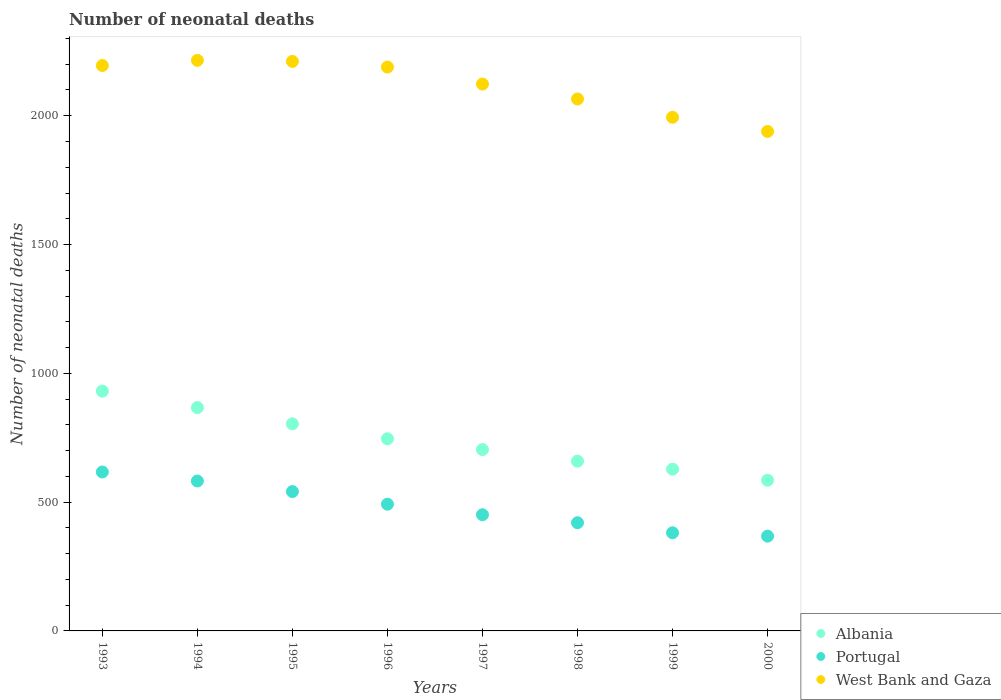What is the number of neonatal deaths in in Portugal in 1993?
Provide a succinct answer. 617. Across all years, what is the maximum number of neonatal deaths in in Portugal?
Make the answer very short. 617. Across all years, what is the minimum number of neonatal deaths in in Portugal?
Ensure brevity in your answer.  368. What is the total number of neonatal deaths in in Albania in the graph?
Your answer should be very brief. 5924. What is the difference between the number of neonatal deaths in in Albania in 1993 and that in 1998?
Make the answer very short. 272. What is the difference between the number of neonatal deaths in in West Bank and Gaza in 1998 and the number of neonatal deaths in in Albania in 1997?
Give a very brief answer. 1361. What is the average number of neonatal deaths in in Albania per year?
Offer a terse response. 740.5. In the year 1998, what is the difference between the number of neonatal deaths in in West Bank and Gaza and number of neonatal deaths in in Albania?
Your answer should be very brief. 1406. What is the ratio of the number of neonatal deaths in in Portugal in 1995 to that in 1999?
Offer a terse response. 1.42. What is the difference between the highest and the second highest number of neonatal deaths in in West Bank and Gaza?
Your response must be concise. 4. What is the difference between the highest and the lowest number of neonatal deaths in in Albania?
Ensure brevity in your answer.  346. Is the sum of the number of neonatal deaths in in Portugal in 1998 and 1999 greater than the maximum number of neonatal deaths in in Albania across all years?
Your response must be concise. No. Is it the case that in every year, the sum of the number of neonatal deaths in in Albania and number of neonatal deaths in in West Bank and Gaza  is greater than the number of neonatal deaths in in Portugal?
Give a very brief answer. Yes. Does the number of neonatal deaths in in Albania monotonically increase over the years?
Your answer should be very brief. No. Is the number of neonatal deaths in in Portugal strictly less than the number of neonatal deaths in in Albania over the years?
Provide a short and direct response. Yes. How many years are there in the graph?
Your response must be concise. 8. What is the difference between two consecutive major ticks on the Y-axis?
Provide a short and direct response. 500. Does the graph contain grids?
Ensure brevity in your answer.  No. How many legend labels are there?
Make the answer very short. 3. What is the title of the graph?
Make the answer very short. Number of neonatal deaths. What is the label or title of the Y-axis?
Provide a succinct answer. Number of neonatal deaths. What is the Number of neonatal deaths in Albania in 1993?
Give a very brief answer. 931. What is the Number of neonatal deaths of Portugal in 1993?
Provide a succinct answer. 617. What is the Number of neonatal deaths in West Bank and Gaza in 1993?
Offer a terse response. 2195. What is the Number of neonatal deaths in Albania in 1994?
Offer a terse response. 867. What is the Number of neonatal deaths of Portugal in 1994?
Your answer should be compact. 582. What is the Number of neonatal deaths in West Bank and Gaza in 1994?
Give a very brief answer. 2215. What is the Number of neonatal deaths in Albania in 1995?
Ensure brevity in your answer.  804. What is the Number of neonatal deaths of Portugal in 1995?
Offer a terse response. 541. What is the Number of neonatal deaths of West Bank and Gaza in 1995?
Make the answer very short. 2211. What is the Number of neonatal deaths in Albania in 1996?
Provide a short and direct response. 746. What is the Number of neonatal deaths of Portugal in 1996?
Offer a very short reply. 492. What is the Number of neonatal deaths in West Bank and Gaza in 1996?
Your response must be concise. 2189. What is the Number of neonatal deaths of Albania in 1997?
Provide a succinct answer. 704. What is the Number of neonatal deaths of Portugal in 1997?
Provide a succinct answer. 451. What is the Number of neonatal deaths in West Bank and Gaza in 1997?
Provide a short and direct response. 2123. What is the Number of neonatal deaths of Albania in 1998?
Offer a terse response. 659. What is the Number of neonatal deaths of Portugal in 1998?
Give a very brief answer. 420. What is the Number of neonatal deaths in West Bank and Gaza in 1998?
Offer a very short reply. 2065. What is the Number of neonatal deaths of Albania in 1999?
Offer a terse response. 628. What is the Number of neonatal deaths in Portugal in 1999?
Provide a short and direct response. 381. What is the Number of neonatal deaths of West Bank and Gaza in 1999?
Provide a succinct answer. 1994. What is the Number of neonatal deaths in Albania in 2000?
Make the answer very short. 585. What is the Number of neonatal deaths of Portugal in 2000?
Your answer should be very brief. 368. What is the Number of neonatal deaths in West Bank and Gaza in 2000?
Ensure brevity in your answer.  1939. Across all years, what is the maximum Number of neonatal deaths in Albania?
Offer a terse response. 931. Across all years, what is the maximum Number of neonatal deaths of Portugal?
Ensure brevity in your answer.  617. Across all years, what is the maximum Number of neonatal deaths in West Bank and Gaza?
Keep it short and to the point. 2215. Across all years, what is the minimum Number of neonatal deaths of Albania?
Make the answer very short. 585. Across all years, what is the minimum Number of neonatal deaths in Portugal?
Your answer should be compact. 368. Across all years, what is the minimum Number of neonatal deaths in West Bank and Gaza?
Provide a succinct answer. 1939. What is the total Number of neonatal deaths of Albania in the graph?
Give a very brief answer. 5924. What is the total Number of neonatal deaths in Portugal in the graph?
Give a very brief answer. 3852. What is the total Number of neonatal deaths in West Bank and Gaza in the graph?
Make the answer very short. 1.69e+04. What is the difference between the Number of neonatal deaths of Albania in 1993 and that in 1994?
Give a very brief answer. 64. What is the difference between the Number of neonatal deaths in Portugal in 1993 and that in 1994?
Make the answer very short. 35. What is the difference between the Number of neonatal deaths in Albania in 1993 and that in 1995?
Provide a succinct answer. 127. What is the difference between the Number of neonatal deaths in Portugal in 1993 and that in 1995?
Your answer should be compact. 76. What is the difference between the Number of neonatal deaths in West Bank and Gaza in 1993 and that in 1995?
Give a very brief answer. -16. What is the difference between the Number of neonatal deaths in Albania in 1993 and that in 1996?
Your answer should be compact. 185. What is the difference between the Number of neonatal deaths of Portugal in 1993 and that in 1996?
Your answer should be compact. 125. What is the difference between the Number of neonatal deaths in Albania in 1993 and that in 1997?
Provide a succinct answer. 227. What is the difference between the Number of neonatal deaths of Portugal in 1993 and that in 1997?
Your answer should be compact. 166. What is the difference between the Number of neonatal deaths of Albania in 1993 and that in 1998?
Offer a very short reply. 272. What is the difference between the Number of neonatal deaths in Portugal in 1993 and that in 1998?
Offer a terse response. 197. What is the difference between the Number of neonatal deaths in West Bank and Gaza in 1993 and that in 1998?
Offer a terse response. 130. What is the difference between the Number of neonatal deaths in Albania in 1993 and that in 1999?
Make the answer very short. 303. What is the difference between the Number of neonatal deaths of Portugal in 1993 and that in 1999?
Offer a very short reply. 236. What is the difference between the Number of neonatal deaths of West Bank and Gaza in 1993 and that in 1999?
Your response must be concise. 201. What is the difference between the Number of neonatal deaths of Albania in 1993 and that in 2000?
Provide a short and direct response. 346. What is the difference between the Number of neonatal deaths in Portugal in 1993 and that in 2000?
Keep it short and to the point. 249. What is the difference between the Number of neonatal deaths of West Bank and Gaza in 1993 and that in 2000?
Your answer should be very brief. 256. What is the difference between the Number of neonatal deaths of Portugal in 1994 and that in 1995?
Your answer should be compact. 41. What is the difference between the Number of neonatal deaths in Albania in 1994 and that in 1996?
Provide a short and direct response. 121. What is the difference between the Number of neonatal deaths in West Bank and Gaza in 1994 and that in 1996?
Offer a very short reply. 26. What is the difference between the Number of neonatal deaths of Albania in 1994 and that in 1997?
Offer a terse response. 163. What is the difference between the Number of neonatal deaths of Portugal in 1994 and that in 1997?
Provide a short and direct response. 131. What is the difference between the Number of neonatal deaths in West Bank and Gaza in 1994 and that in 1997?
Your answer should be compact. 92. What is the difference between the Number of neonatal deaths in Albania in 1994 and that in 1998?
Keep it short and to the point. 208. What is the difference between the Number of neonatal deaths of Portugal in 1994 and that in 1998?
Ensure brevity in your answer.  162. What is the difference between the Number of neonatal deaths of West Bank and Gaza in 1994 and that in 1998?
Provide a short and direct response. 150. What is the difference between the Number of neonatal deaths of Albania in 1994 and that in 1999?
Ensure brevity in your answer.  239. What is the difference between the Number of neonatal deaths of Portugal in 1994 and that in 1999?
Give a very brief answer. 201. What is the difference between the Number of neonatal deaths of West Bank and Gaza in 1994 and that in 1999?
Offer a terse response. 221. What is the difference between the Number of neonatal deaths in Albania in 1994 and that in 2000?
Give a very brief answer. 282. What is the difference between the Number of neonatal deaths in Portugal in 1994 and that in 2000?
Your response must be concise. 214. What is the difference between the Number of neonatal deaths of West Bank and Gaza in 1994 and that in 2000?
Give a very brief answer. 276. What is the difference between the Number of neonatal deaths in West Bank and Gaza in 1995 and that in 1996?
Provide a succinct answer. 22. What is the difference between the Number of neonatal deaths in Albania in 1995 and that in 1997?
Ensure brevity in your answer.  100. What is the difference between the Number of neonatal deaths in Albania in 1995 and that in 1998?
Your answer should be compact. 145. What is the difference between the Number of neonatal deaths in Portugal in 1995 and that in 1998?
Give a very brief answer. 121. What is the difference between the Number of neonatal deaths in West Bank and Gaza in 1995 and that in 1998?
Your answer should be very brief. 146. What is the difference between the Number of neonatal deaths of Albania in 1995 and that in 1999?
Provide a short and direct response. 176. What is the difference between the Number of neonatal deaths in Portugal in 1995 and that in 1999?
Ensure brevity in your answer.  160. What is the difference between the Number of neonatal deaths of West Bank and Gaza in 1995 and that in 1999?
Your answer should be compact. 217. What is the difference between the Number of neonatal deaths in Albania in 1995 and that in 2000?
Your response must be concise. 219. What is the difference between the Number of neonatal deaths in Portugal in 1995 and that in 2000?
Provide a succinct answer. 173. What is the difference between the Number of neonatal deaths in West Bank and Gaza in 1995 and that in 2000?
Offer a very short reply. 272. What is the difference between the Number of neonatal deaths of Albania in 1996 and that in 1997?
Your response must be concise. 42. What is the difference between the Number of neonatal deaths in West Bank and Gaza in 1996 and that in 1997?
Offer a very short reply. 66. What is the difference between the Number of neonatal deaths in Albania in 1996 and that in 1998?
Provide a short and direct response. 87. What is the difference between the Number of neonatal deaths of Portugal in 1996 and that in 1998?
Offer a very short reply. 72. What is the difference between the Number of neonatal deaths of West Bank and Gaza in 1996 and that in 1998?
Give a very brief answer. 124. What is the difference between the Number of neonatal deaths of Albania in 1996 and that in 1999?
Your answer should be very brief. 118. What is the difference between the Number of neonatal deaths in Portugal in 1996 and that in 1999?
Offer a terse response. 111. What is the difference between the Number of neonatal deaths of West Bank and Gaza in 1996 and that in 1999?
Provide a short and direct response. 195. What is the difference between the Number of neonatal deaths of Albania in 1996 and that in 2000?
Your response must be concise. 161. What is the difference between the Number of neonatal deaths in Portugal in 1996 and that in 2000?
Give a very brief answer. 124. What is the difference between the Number of neonatal deaths of West Bank and Gaza in 1996 and that in 2000?
Provide a succinct answer. 250. What is the difference between the Number of neonatal deaths in Albania in 1997 and that in 1998?
Ensure brevity in your answer.  45. What is the difference between the Number of neonatal deaths in Portugal in 1997 and that in 1998?
Provide a succinct answer. 31. What is the difference between the Number of neonatal deaths of West Bank and Gaza in 1997 and that in 1998?
Ensure brevity in your answer.  58. What is the difference between the Number of neonatal deaths of West Bank and Gaza in 1997 and that in 1999?
Provide a short and direct response. 129. What is the difference between the Number of neonatal deaths in Albania in 1997 and that in 2000?
Provide a short and direct response. 119. What is the difference between the Number of neonatal deaths in West Bank and Gaza in 1997 and that in 2000?
Your answer should be very brief. 184. What is the difference between the Number of neonatal deaths in Albania in 1998 and that in 1999?
Your response must be concise. 31. What is the difference between the Number of neonatal deaths in Portugal in 1998 and that in 1999?
Provide a succinct answer. 39. What is the difference between the Number of neonatal deaths in West Bank and Gaza in 1998 and that in 1999?
Provide a succinct answer. 71. What is the difference between the Number of neonatal deaths in West Bank and Gaza in 1998 and that in 2000?
Provide a short and direct response. 126. What is the difference between the Number of neonatal deaths in Portugal in 1999 and that in 2000?
Offer a terse response. 13. What is the difference between the Number of neonatal deaths in West Bank and Gaza in 1999 and that in 2000?
Provide a succinct answer. 55. What is the difference between the Number of neonatal deaths in Albania in 1993 and the Number of neonatal deaths in Portugal in 1994?
Provide a short and direct response. 349. What is the difference between the Number of neonatal deaths of Albania in 1993 and the Number of neonatal deaths of West Bank and Gaza in 1994?
Provide a succinct answer. -1284. What is the difference between the Number of neonatal deaths of Portugal in 1993 and the Number of neonatal deaths of West Bank and Gaza in 1994?
Make the answer very short. -1598. What is the difference between the Number of neonatal deaths of Albania in 1993 and the Number of neonatal deaths of Portugal in 1995?
Offer a very short reply. 390. What is the difference between the Number of neonatal deaths of Albania in 1993 and the Number of neonatal deaths of West Bank and Gaza in 1995?
Make the answer very short. -1280. What is the difference between the Number of neonatal deaths in Portugal in 1993 and the Number of neonatal deaths in West Bank and Gaza in 1995?
Ensure brevity in your answer.  -1594. What is the difference between the Number of neonatal deaths in Albania in 1993 and the Number of neonatal deaths in Portugal in 1996?
Provide a succinct answer. 439. What is the difference between the Number of neonatal deaths in Albania in 1993 and the Number of neonatal deaths in West Bank and Gaza in 1996?
Keep it short and to the point. -1258. What is the difference between the Number of neonatal deaths of Portugal in 1993 and the Number of neonatal deaths of West Bank and Gaza in 1996?
Keep it short and to the point. -1572. What is the difference between the Number of neonatal deaths of Albania in 1993 and the Number of neonatal deaths of Portugal in 1997?
Provide a short and direct response. 480. What is the difference between the Number of neonatal deaths of Albania in 1993 and the Number of neonatal deaths of West Bank and Gaza in 1997?
Offer a terse response. -1192. What is the difference between the Number of neonatal deaths in Portugal in 1993 and the Number of neonatal deaths in West Bank and Gaza in 1997?
Provide a succinct answer. -1506. What is the difference between the Number of neonatal deaths of Albania in 1993 and the Number of neonatal deaths of Portugal in 1998?
Your response must be concise. 511. What is the difference between the Number of neonatal deaths of Albania in 1993 and the Number of neonatal deaths of West Bank and Gaza in 1998?
Keep it short and to the point. -1134. What is the difference between the Number of neonatal deaths of Portugal in 1993 and the Number of neonatal deaths of West Bank and Gaza in 1998?
Give a very brief answer. -1448. What is the difference between the Number of neonatal deaths in Albania in 1993 and the Number of neonatal deaths in Portugal in 1999?
Give a very brief answer. 550. What is the difference between the Number of neonatal deaths of Albania in 1993 and the Number of neonatal deaths of West Bank and Gaza in 1999?
Your response must be concise. -1063. What is the difference between the Number of neonatal deaths of Portugal in 1993 and the Number of neonatal deaths of West Bank and Gaza in 1999?
Your response must be concise. -1377. What is the difference between the Number of neonatal deaths of Albania in 1993 and the Number of neonatal deaths of Portugal in 2000?
Your answer should be compact. 563. What is the difference between the Number of neonatal deaths of Albania in 1993 and the Number of neonatal deaths of West Bank and Gaza in 2000?
Offer a very short reply. -1008. What is the difference between the Number of neonatal deaths of Portugal in 1993 and the Number of neonatal deaths of West Bank and Gaza in 2000?
Offer a very short reply. -1322. What is the difference between the Number of neonatal deaths in Albania in 1994 and the Number of neonatal deaths in Portugal in 1995?
Keep it short and to the point. 326. What is the difference between the Number of neonatal deaths in Albania in 1994 and the Number of neonatal deaths in West Bank and Gaza in 1995?
Your response must be concise. -1344. What is the difference between the Number of neonatal deaths of Portugal in 1994 and the Number of neonatal deaths of West Bank and Gaza in 1995?
Your response must be concise. -1629. What is the difference between the Number of neonatal deaths in Albania in 1994 and the Number of neonatal deaths in Portugal in 1996?
Your answer should be very brief. 375. What is the difference between the Number of neonatal deaths of Albania in 1994 and the Number of neonatal deaths of West Bank and Gaza in 1996?
Provide a short and direct response. -1322. What is the difference between the Number of neonatal deaths in Portugal in 1994 and the Number of neonatal deaths in West Bank and Gaza in 1996?
Provide a short and direct response. -1607. What is the difference between the Number of neonatal deaths of Albania in 1994 and the Number of neonatal deaths of Portugal in 1997?
Ensure brevity in your answer.  416. What is the difference between the Number of neonatal deaths in Albania in 1994 and the Number of neonatal deaths in West Bank and Gaza in 1997?
Your answer should be compact. -1256. What is the difference between the Number of neonatal deaths in Portugal in 1994 and the Number of neonatal deaths in West Bank and Gaza in 1997?
Your answer should be compact. -1541. What is the difference between the Number of neonatal deaths in Albania in 1994 and the Number of neonatal deaths in Portugal in 1998?
Offer a very short reply. 447. What is the difference between the Number of neonatal deaths in Albania in 1994 and the Number of neonatal deaths in West Bank and Gaza in 1998?
Provide a short and direct response. -1198. What is the difference between the Number of neonatal deaths of Portugal in 1994 and the Number of neonatal deaths of West Bank and Gaza in 1998?
Make the answer very short. -1483. What is the difference between the Number of neonatal deaths in Albania in 1994 and the Number of neonatal deaths in Portugal in 1999?
Keep it short and to the point. 486. What is the difference between the Number of neonatal deaths of Albania in 1994 and the Number of neonatal deaths of West Bank and Gaza in 1999?
Provide a succinct answer. -1127. What is the difference between the Number of neonatal deaths in Portugal in 1994 and the Number of neonatal deaths in West Bank and Gaza in 1999?
Your answer should be very brief. -1412. What is the difference between the Number of neonatal deaths in Albania in 1994 and the Number of neonatal deaths in Portugal in 2000?
Give a very brief answer. 499. What is the difference between the Number of neonatal deaths of Albania in 1994 and the Number of neonatal deaths of West Bank and Gaza in 2000?
Provide a succinct answer. -1072. What is the difference between the Number of neonatal deaths in Portugal in 1994 and the Number of neonatal deaths in West Bank and Gaza in 2000?
Offer a terse response. -1357. What is the difference between the Number of neonatal deaths of Albania in 1995 and the Number of neonatal deaths of Portugal in 1996?
Keep it short and to the point. 312. What is the difference between the Number of neonatal deaths in Albania in 1995 and the Number of neonatal deaths in West Bank and Gaza in 1996?
Ensure brevity in your answer.  -1385. What is the difference between the Number of neonatal deaths of Portugal in 1995 and the Number of neonatal deaths of West Bank and Gaza in 1996?
Your answer should be compact. -1648. What is the difference between the Number of neonatal deaths in Albania in 1995 and the Number of neonatal deaths in Portugal in 1997?
Make the answer very short. 353. What is the difference between the Number of neonatal deaths of Albania in 1995 and the Number of neonatal deaths of West Bank and Gaza in 1997?
Offer a terse response. -1319. What is the difference between the Number of neonatal deaths of Portugal in 1995 and the Number of neonatal deaths of West Bank and Gaza in 1997?
Your response must be concise. -1582. What is the difference between the Number of neonatal deaths in Albania in 1995 and the Number of neonatal deaths in Portugal in 1998?
Offer a very short reply. 384. What is the difference between the Number of neonatal deaths of Albania in 1995 and the Number of neonatal deaths of West Bank and Gaza in 1998?
Offer a very short reply. -1261. What is the difference between the Number of neonatal deaths of Portugal in 1995 and the Number of neonatal deaths of West Bank and Gaza in 1998?
Keep it short and to the point. -1524. What is the difference between the Number of neonatal deaths of Albania in 1995 and the Number of neonatal deaths of Portugal in 1999?
Ensure brevity in your answer.  423. What is the difference between the Number of neonatal deaths of Albania in 1995 and the Number of neonatal deaths of West Bank and Gaza in 1999?
Keep it short and to the point. -1190. What is the difference between the Number of neonatal deaths of Portugal in 1995 and the Number of neonatal deaths of West Bank and Gaza in 1999?
Make the answer very short. -1453. What is the difference between the Number of neonatal deaths of Albania in 1995 and the Number of neonatal deaths of Portugal in 2000?
Your answer should be compact. 436. What is the difference between the Number of neonatal deaths of Albania in 1995 and the Number of neonatal deaths of West Bank and Gaza in 2000?
Your response must be concise. -1135. What is the difference between the Number of neonatal deaths in Portugal in 1995 and the Number of neonatal deaths in West Bank and Gaza in 2000?
Offer a terse response. -1398. What is the difference between the Number of neonatal deaths in Albania in 1996 and the Number of neonatal deaths in Portugal in 1997?
Ensure brevity in your answer.  295. What is the difference between the Number of neonatal deaths in Albania in 1996 and the Number of neonatal deaths in West Bank and Gaza in 1997?
Ensure brevity in your answer.  -1377. What is the difference between the Number of neonatal deaths of Portugal in 1996 and the Number of neonatal deaths of West Bank and Gaza in 1997?
Offer a terse response. -1631. What is the difference between the Number of neonatal deaths in Albania in 1996 and the Number of neonatal deaths in Portugal in 1998?
Make the answer very short. 326. What is the difference between the Number of neonatal deaths of Albania in 1996 and the Number of neonatal deaths of West Bank and Gaza in 1998?
Provide a succinct answer. -1319. What is the difference between the Number of neonatal deaths in Portugal in 1996 and the Number of neonatal deaths in West Bank and Gaza in 1998?
Your answer should be compact. -1573. What is the difference between the Number of neonatal deaths in Albania in 1996 and the Number of neonatal deaths in Portugal in 1999?
Make the answer very short. 365. What is the difference between the Number of neonatal deaths of Albania in 1996 and the Number of neonatal deaths of West Bank and Gaza in 1999?
Offer a terse response. -1248. What is the difference between the Number of neonatal deaths in Portugal in 1996 and the Number of neonatal deaths in West Bank and Gaza in 1999?
Keep it short and to the point. -1502. What is the difference between the Number of neonatal deaths of Albania in 1996 and the Number of neonatal deaths of Portugal in 2000?
Offer a very short reply. 378. What is the difference between the Number of neonatal deaths of Albania in 1996 and the Number of neonatal deaths of West Bank and Gaza in 2000?
Offer a terse response. -1193. What is the difference between the Number of neonatal deaths in Portugal in 1996 and the Number of neonatal deaths in West Bank and Gaza in 2000?
Your answer should be compact. -1447. What is the difference between the Number of neonatal deaths of Albania in 1997 and the Number of neonatal deaths of Portugal in 1998?
Make the answer very short. 284. What is the difference between the Number of neonatal deaths of Albania in 1997 and the Number of neonatal deaths of West Bank and Gaza in 1998?
Your response must be concise. -1361. What is the difference between the Number of neonatal deaths of Portugal in 1997 and the Number of neonatal deaths of West Bank and Gaza in 1998?
Ensure brevity in your answer.  -1614. What is the difference between the Number of neonatal deaths of Albania in 1997 and the Number of neonatal deaths of Portugal in 1999?
Your response must be concise. 323. What is the difference between the Number of neonatal deaths in Albania in 1997 and the Number of neonatal deaths in West Bank and Gaza in 1999?
Your response must be concise. -1290. What is the difference between the Number of neonatal deaths of Portugal in 1997 and the Number of neonatal deaths of West Bank and Gaza in 1999?
Give a very brief answer. -1543. What is the difference between the Number of neonatal deaths of Albania in 1997 and the Number of neonatal deaths of Portugal in 2000?
Your response must be concise. 336. What is the difference between the Number of neonatal deaths in Albania in 1997 and the Number of neonatal deaths in West Bank and Gaza in 2000?
Keep it short and to the point. -1235. What is the difference between the Number of neonatal deaths of Portugal in 1997 and the Number of neonatal deaths of West Bank and Gaza in 2000?
Make the answer very short. -1488. What is the difference between the Number of neonatal deaths of Albania in 1998 and the Number of neonatal deaths of Portugal in 1999?
Offer a terse response. 278. What is the difference between the Number of neonatal deaths of Albania in 1998 and the Number of neonatal deaths of West Bank and Gaza in 1999?
Provide a short and direct response. -1335. What is the difference between the Number of neonatal deaths of Portugal in 1998 and the Number of neonatal deaths of West Bank and Gaza in 1999?
Keep it short and to the point. -1574. What is the difference between the Number of neonatal deaths in Albania in 1998 and the Number of neonatal deaths in Portugal in 2000?
Your response must be concise. 291. What is the difference between the Number of neonatal deaths in Albania in 1998 and the Number of neonatal deaths in West Bank and Gaza in 2000?
Give a very brief answer. -1280. What is the difference between the Number of neonatal deaths of Portugal in 1998 and the Number of neonatal deaths of West Bank and Gaza in 2000?
Offer a very short reply. -1519. What is the difference between the Number of neonatal deaths in Albania in 1999 and the Number of neonatal deaths in Portugal in 2000?
Provide a short and direct response. 260. What is the difference between the Number of neonatal deaths of Albania in 1999 and the Number of neonatal deaths of West Bank and Gaza in 2000?
Your response must be concise. -1311. What is the difference between the Number of neonatal deaths of Portugal in 1999 and the Number of neonatal deaths of West Bank and Gaza in 2000?
Offer a terse response. -1558. What is the average Number of neonatal deaths of Albania per year?
Your answer should be very brief. 740.5. What is the average Number of neonatal deaths of Portugal per year?
Make the answer very short. 481.5. What is the average Number of neonatal deaths of West Bank and Gaza per year?
Your response must be concise. 2116.38. In the year 1993, what is the difference between the Number of neonatal deaths of Albania and Number of neonatal deaths of Portugal?
Offer a very short reply. 314. In the year 1993, what is the difference between the Number of neonatal deaths of Albania and Number of neonatal deaths of West Bank and Gaza?
Make the answer very short. -1264. In the year 1993, what is the difference between the Number of neonatal deaths in Portugal and Number of neonatal deaths in West Bank and Gaza?
Provide a short and direct response. -1578. In the year 1994, what is the difference between the Number of neonatal deaths in Albania and Number of neonatal deaths in Portugal?
Offer a terse response. 285. In the year 1994, what is the difference between the Number of neonatal deaths of Albania and Number of neonatal deaths of West Bank and Gaza?
Your answer should be very brief. -1348. In the year 1994, what is the difference between the Number of neonatal deaths in Portugal and Number of neonatal deaths in West Bank and Gaza?
Make the answer very short. -1633. In the year 1995, what is the difference between the Number of neonatal deaths of Albania and Number of neonatal deaths of Portugal?
Offer a terse response. 263. In the year 1995, what is the difference between the Number of neonatal deaths of Albania and Number of neonatal deaths of West Bank and Gaza?
Keep it short and to the point. -1407. In the year 1995, what is the difference between the Number of neonatal deaths of Portugal and Number of neonatal deaths of West Bank and Gaza?
Ensure brevity in your answer.  -1670. In the year 1996, what is the difference between the Number of neonatal deaths in Albania and Number of neonatal deaths in Portugal?
Provide a succinct answer. 254. In the year 1996, what is the difference between the Number of neonatal deaths of Albania and Number of neonatal deaths of West Bank and Gaza?
Provide a succinct answer. -1443. In the year 1996, what is the difference between the Number of neonatal deaths in Portugal and Number of neonatal deaths in West Bank and Gaza?
Your answer should be very brief. -1697. In the year 1997, what is the difference between the Number of neonatal deaths of Albania and Number of neonatal deaths of Portugal?
Your response must be concise. 253. In the year 1997, what is the difference between the Number of neonatal deaths of Albania and Number of neonatal deaths of West Bank and Gaza?
Your answer should be compact. -1419. In the year 1997, what is the difference between the Number of neonatal deaths in Portugal and Number of neonatal deaths in West Bank and Gaza?
Keep it short and to the point. -1672. In the year 1998, what is the difference between the Number of neonatal deaths in Albania and Number of neonatal deaths in Portugal?
Provide a short and direct response. 239. In the year 1998, what is the difference between the Number of neonatal deaths of Albania and Number of neonatal deaths of West Bank and Gaza?
Provide a succinct answer. -1406. In the year 1998, what is the difference between the Number of neonatal deaths of Portugal and Number of neonatal deaths of West Bank and Gaza?
Give a very brief answer. -1645. In the year 1999, what is the difference between the Number of neonatal deaths of Albania and Number of neonatal deaths of Portugal?
Provide a succinct answer. 247. In the year 1999, what is the difference between the Number of neonatal deaths in Albania and Number of neonatal deaths in West Bank and Gaza?
Your response must be concise. -1366. In the year 1999, what is the difference between the Number of neonatal deaths of Portugal and Number of neonatal deaths of West Bank and Gaza?
Offer a terse response. -1613. In the year 2000, what is the difference between the Number of neonatal deaths of Albania and Number of neonatal deaths of Portugal?
Your answer should be very brief. 217. In the year 2000, what is the difference between the Number of neonatal deaths of Albania and Number of neonatal deaths of West Bank and Gaza?
Offer a terse response. -1354. In the year 2000, what is the difference between the Number of neonatal deaths in Portugal and Number of neonatal deaths in West Bank and Gaza?
Make the answer very short. -1571. What is the ratio of the Number of neonatal deaths in Albania in 1993 to that in 1994?
Give a very brief answer. 1.07. What is the ratio of the Number of neonatal deaths in Portugal in 1993 to that in 1994?
Provide a succinct answer. 1.06. What is the ratio of the Number of neonatal deaths of Albania in 1993 to that in 1995?
Make the answer very short. 1.16. What is the ratio of the Number of neonatal deaths in Portugal in 1993 to that in 1995?
Your answer should be compact. 1.14. What is the ratio of the Number of neonatal deaths in West Bank and Gaza in 1993 to that in 1995?
Give a very brief answer. 0.99. What is the ratio of the Number of neonatal deaths of Albania in 1993 to that in 1996?
Ensure brevity in your answer.  1.25. What is the ratio of the Number of neonatal deaths of Portugal in 1993 to that in 1996?
Keep it short and to the point. 1.25. What is the ratio of the Number of neonatal deaths in West Bank and Gaza in 1993 to that in 1996?
Your answer should be very brief. 1. What is the ratio of the Number of neonatal deaths in Albania in 1993 to that in 1997?
Provide a succinct answer. 1.32. What is the ratio of the Number of neonatal deaths of Portugal in 1993 to that in 1997?
Ensure brevity in your answer.  1.37. What is the ratio of the Number of neonatal deaths of West Bank and Gaza in 1993 to that in 1997?
Provide a succinct answer. 1.03. What is the ratio of the Number of neonatal deaths in Albania in 1993 to that in 1998?
Offer a terse response. 1.41. What is the ratio of the Number of neonatal deaths of Portugal in 1993 to that in 1998?
Ensure brevity in your answer.  1.47. What is the ratio of the Number of neonatal deaths in West Bank and Gaza in 1993 to that in 1998?
Your answer should be very brief. 1.06. What is the ratio of the Number of neonatal deaths in Albania in 1993 to that in 1999?
Your response must be concise. 1.48. What is the ratio of the Number of neonatal deaths in Portugal in 1993 to that in 1999?
Offer a very short reply. 1.62. What is the ratio of the Number of neonatal deaths in West Bank and Gaza in 1993 to that in 1999?
Your answer should be compact. 1.1. What is the ratio of the Number of neonatal deaths in Albania in 1993 to that in 2000?
Offer a very short reply. 1.59. What is the ratio of the Number of neonatal deaths in Portugal in 1993 to that in 2000?
Provide a succinct answer. 1.68. What is the ratio of the Number of neonatal deaths in West Bank and Gaza in 1993 to that in 2000?
Offer a terse response. 1.13. What is the ratio of the Number of neonatal deaths in Albania in 1994 to that in 1995?
Make the answer very short. 1.08. What is the ratio of the Number of neonatal deaths of Portugal in 1994 to that in 1995?
Ensure brevity in your answer.  1.08. What is the ratio of the Number of neonatal deaths in Albania in 1994 to that in 1996?
Offer a terse response. 1.16. What is the ratio of the Number of neonatal deaths of Portugal in 1994 to that in 1996?
Keep it short and to the point. 1.18. What is the ratio of the Number of neonatal deaths of West Bank and Gaza in 1994 to that in 1996?
Keep it short and to the point. 1.01. What is the ratio of the Number of neonatal deaths of Albania in 1994 to that in 1997?
Your answer should be compact. 1.23. What is the ratio of the Number of neonatal deaths in Portugal in 1994 to that in 1997?
Your response must be concise. 1.29. What is the ratio of the Number of neonatal deaths of West Bank and Gaza in 1994 to that in 1997?
Give a very brief answer. 1.04. What is the ratio of the Number of neonatal deaths of Albania in 1994 to that in 1998?
Offer a terse response. 1.32. What is the ratio of the Number of neonatal deaths in Portugal in 1994 to that in 1998?
Offer a terse response. 1.39. What is the ratio of the Number of neonatal deaths of West Bank and Gaza in 1994 to that in 1998?
Offer a very short reply. 1.07. What is the ratio of the Number of neonatal deaths of Albania in 1994 to that in 1999?
Give a very brief answer. 1.38. What is the ratio of the Number of neonatal deaths of Portugal in 1994 to that in 1999?
Give a very brief answer. 1.53. What is the ratio of the Number of neonatal deaths of West Bank and Gaza in 1994 to that in 1999?
Provide a short and direct response. 1.11. What is the ratio of the Number of neonatal deaths in Albania in 1994 to that in 2000?
Your answer should be very brief. 1.48. What is the ratio of the Number of neonatal deaths in Portugal in 1994 to that in 2000?
Provide a short and direct response. 1.58. What is the ratio of the Number of neonatal deaths of West Bank and Gaza in 1994 to that in 2000?
Your answer should be very brief. 1.14. What is the ratio of the Number of neonatal deaths of Albania in 1995 to that in 1996?
Keep it short and to the point. 1.08. What is the ratio of the Number of neonatal deaths in Portugal in 1995 to that in 1996?
Your response must be concise. 1.1. What is the ratio of the Number of neonatal deaths of West Bank and Gaza in 1995 to that in 1996?
Offer a very short reply. 1.01. What is the ratio of the Number of neonatal deaths of Albania in 1995 to that in 1997?
Your response must be concise. 1.14. What is the ratio of the Number of neonatal deaths in Portugal in 1995 to that in 1997?
Your answer should be very brief. 1.2. What is the ratio of the Number of neonatal deaths in West Bank and Gaza in 1995 to that in 1997?
Your response must be concise. 1.04. What is the ratio of the Number of neonatal deaths of Albania in 1995 to that in 1998?
Give a very brief answer. 1.22. What is the ratio of the Number of neonatal deaths in Portugal in 1995 to that in 1998?
Your answer should be compact. 1.29. What is the ratio of the Number of neonatal deaths of West Bank and Gaza in 1995 to that in 1998?
Give a very brief answer. 1.07. What is the ratio of the Number of neonatal deaths of Albania in 1995 to that in 1999?
Your response must be concise. 1.28. What is the ratio of the Number of neonatal deaths of Portugal in 1995 to that in 1999?
Ensure brevity in your answer.  1.42. What is the ratio of the Number of neonatal deaths of West Bank and Gaza in 1995 to that in 1999?
Keep it short and to the point. 1.11. What is the ratio of the Number of neonatal deaths of Albania in 1995 to that in 2000?
Make the answer very short. 1.37. What is the ratio of the Number of neonatal deaths of Portugal in 1995 to that in 2000?
Offer a very short reply. 1.47. What is the ratio of the Number of neonatal deaths in West Bank and Gaza in 1995 to that in 2000?
Ensure brevity in your answer.  1.14. What is the ratio of the Number of neonatal deaths of Albania in 1996 to that in 1997?
Your response must be concise. 1.06. What is the ratio of the Number of neonatal deaths in Portugal in 1996 to that in 1997?
Keep it short and to the point. 1.09. What is the ratio of the Number of neonatal deaths of West Bank and Gaza in 1996 to that in 1997?
Provide a succinct answer. 1.03. What is the ratio of the Number of neonatal deaths in Albania in 1996 to that in 1998?
Your answer should be compact. 1.13. What is the ratio of the Number of neonatal deaths of Portugal in 1996 to that in 1998?
Your answer should be very brief. 1.17. What is the ratio of the Number of neonatal deaths of West Bank and Gaza in 1996 to that in 1998?
Your answer should be compact. 1.06. What is the ratio of the Number of neonatal deaths of Albania in 1996 to that in 1999?
Provide a succinct answer. 1.19. What is the ratio of the Number of neonatal deaths in Portugal in 1996 to that in 1999?
Offer a terse response. 1.29. What is the ratio of the Number of neonatal deaths in West Bank and Gaza in 1996 to that in 1999?
Your answer should be compact. 1.1. What is the ratio of the Number of neonatal deaths in Albania in 1996 to that in 2000?
Make the answer very short. 1.28. What is the ratio of the Number of neonatal deaths in Portugal in 1996 to that in 2000?
Your response must be concise. 1.34. What is the ratio of the Number of neonatal deaths in West Bank and Gaza in 1996 to that in 2000?
Keep it short and to the point. 1.13. What is the ratio of the Number of neonatal deaths of Albania in 1997 to that in 1998?
Ensure brevity in your answer.  1.07. What is the ratio of the Number of neonatal deaths of Portugal in 1997 to that in 1998?
Provide a short and direct response. 1.07. What is the ratio of the Number of neonatal deaths in West Bank and Gaza in 1997 to that in 1998?
Provide a succinct answer. 1.03. What is the ratio of the Number of neonatal deaths of Albania in 1997 to that in 1999?
Keep it short and to the point. 1.12. What is the ratio of the Number of neonatal deaths in Portugal in 1997 to that in 1999?
Keep it short and to the point. 1.18. What is the ratio of the Number of neonatal deaths in West Bank and Gaza in 1997 to that in 1999?
Ensure brevity in your answer.  1.06. What is the ratio of the Number of neonatal deaths of Albania in 1997 to that in 2000?
Your answer should be very brief. 1.2. What is the ratio of the Number of neonatal deaths of Portugal in 1997 to that in 2000?
Your answer should be compact. 1.23. What is the ratio of the Number of neonatal deaths of West Bank and Gaza in 1997 to that in 2000?
Your answer should be very brief. 1.09. What is the ratio of the Number of neonatal deaths in Albania in 1998 to that in 1999?
Keep it short and to the point. 1.05. What is the ratio of the Number of neonatal deaths in Portugal in 1998 to that in 1999?
Offer a very short reply. 1.1. What is the ratio of the Number of neonatal deaths of West Bank and Gaza in 1998 to that in 1999?
Make the answer very short. 1.04. What is the ratio of the Number of neonatal deaths in Albania in 1998 to that in 2000?
Make the answer very short. 1.13. What is the ratio of the Number of neonatal deaths of Portugal in 1998 to that in 2000?
Give a very brief answer. 1.14. What is the ratio of the Number of neonatal deaths of West Bank and Gaza in 1998 to that in 2000?
Offer a very short reply. 1.06. What is the ratio of the Number of neonatal deaths in Albania in 1999 to that in 2000?
Offer a very short reply. 1.07. What is the ratio of the Number of neonatal deaths in Portugal in 1999 to that in 2000?
Your response must be concise. 1.04. What is the ratio of the Number of neonatal deaths of West Bank and Gaza in 1999 to that in 2000?
Your response must be concise. 1.03. What is the difference between the highest and the second highest Number of neonatal deaths of Albania?
Offer a very short reply. 64. What is the difference between the highest and the second highest Number of neonatal deaths in Portugal?
Provide a succinct answer. 35. What is the difference between the highest and the second highest Number of neonatal deaths in West Bank and Gaza?
Keep it short and to the point. 4. What is the difference between the highest and the lowest Number of neonatal deaths in Albania?
Offer a terse response. 346. What is the difference between the highest and the lowest Number of neonatal deaths of Portugal?
Ensure brevity in your answer.  249. What is the difference between the highest and the lowest Number of neonatal deaths of West Bank and Gaza?
Your response must be concise. 276. 